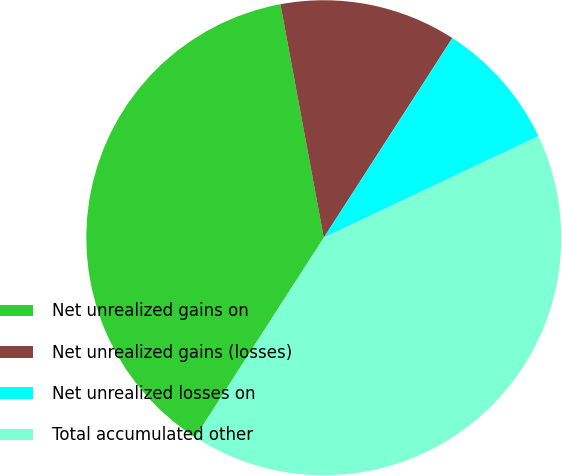Convert chart to OTSL. <chart><loc_0><loc_0><loc_500><loc_500><pie_chart><fcel>Net unrealized gains on<fcel>Net unrealized gains (losses)<fcel>Net unrealized losses on<fcel>Total accumulated other<nl><fcel>37.97%<fcel>12.03%<fcel>8.86%<fcel>41.14%<nl></chart> 